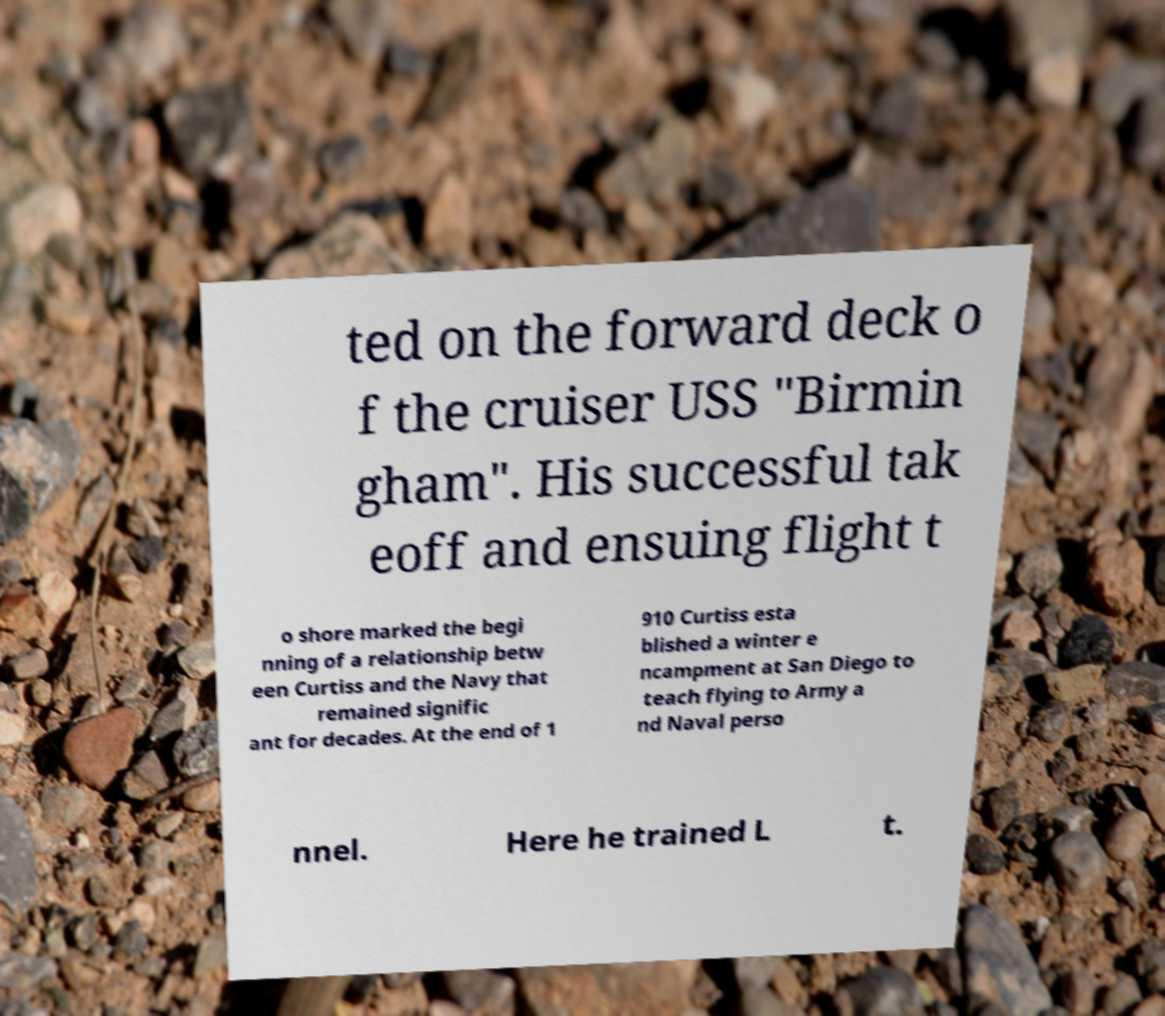For documentation purposes, I need the text within this image transcribed. Could you provide that? ted on the forward deck o f the cruiser USS "Birmin gham". His successful tak eoff and ensuing flight t o shore marked the begi nning of a relationship betw een Curtiss and the Navy that remained signific ant for decades. At the end of 1 910 Curtiss esta blished a winter e ncampment at San Diego to teach flying to Army a nd Naval perso nnel. Here he trained L t. 